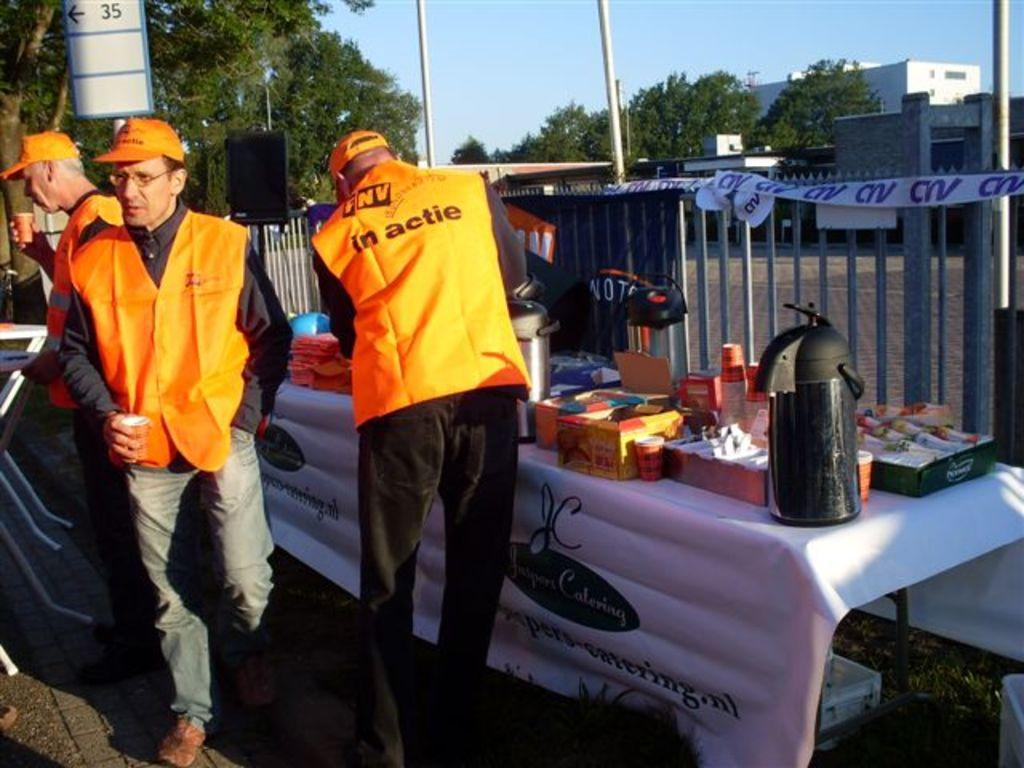How many men are in the image? There are three men in the image. What are the men wearing? The men are wearing the same dress. What can be seen in the image besides the men? There is a table with multiple objects on it, and there are trees, poles, buildings, and the sky visible in the background of the image. Can you see a kitty playing with a wax candle on the table in the image? No, there is no kitty or wax candle present on the table in the image. 